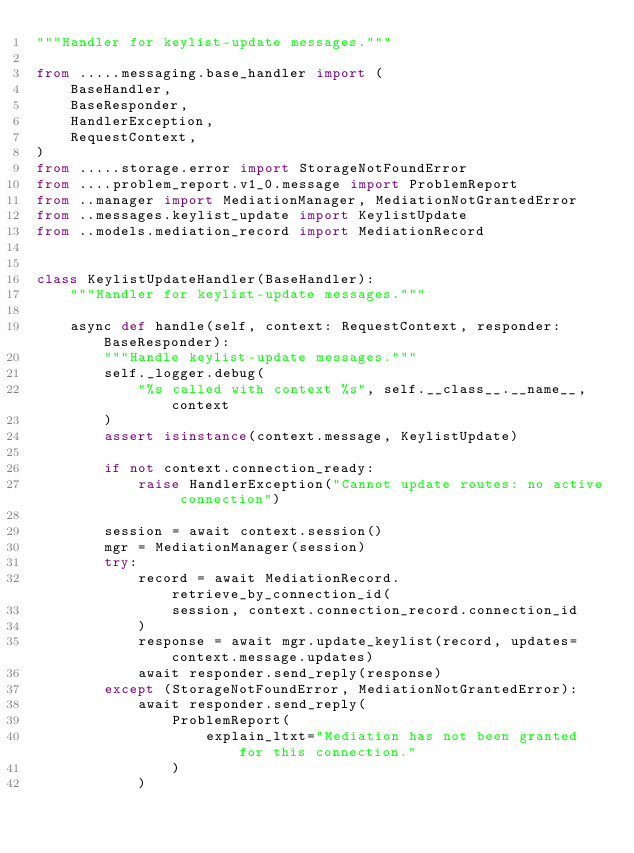<code> <loc_0><loc_0><loc_500><loc_500><_Python_>"""Handler for keylist-update messages."""

from .....messaging.base_handler import (
    BaseHandler,
    BaseResponder,
    HandlerException,
    RequestContext,
)
from .....storage.error import StorageNotFoundError
from ....problem_report.v1_0.message import ProblemReport
from ..manager import MediationManager, MediationNotGrantedError
from ..messages.keylist_update import KeylistUpdate
from ..models.mediation_record import MediationRecord


class KeylistUpdateHandler(BaseHandler):
    """Handler for keylist-update messages."""

    async def handle(self, context: RequestContext, responder: BaseResponder):
        """Handle keylist-update messages."""
        self._logger.debug(
            "%s called with context %s", self.__class__.__name__, context
        )
        assert isinstance(context.message, KeylistUpdate)

        if not context.connection_ready:
            raise HandlerException("Cannot update routes: no active connection")

        session = await context.session()
        mgr = MediationManager(session)
        try:
            record = await MediationRecord.retrieve_by_connection_id(
                session, context.connection_record.connection_id
            )
            response = await mgr.update_keylist(record, updates=context.message.updates)
            await responder.send_reply(response)
        except (StorageNotFoundError, MediationNotGrantedError):
            await responder.send_reply(
                ProblemReport(
                    explain_ltxt="Mediation has not been granted for this connection."
                )
            )
</code> 